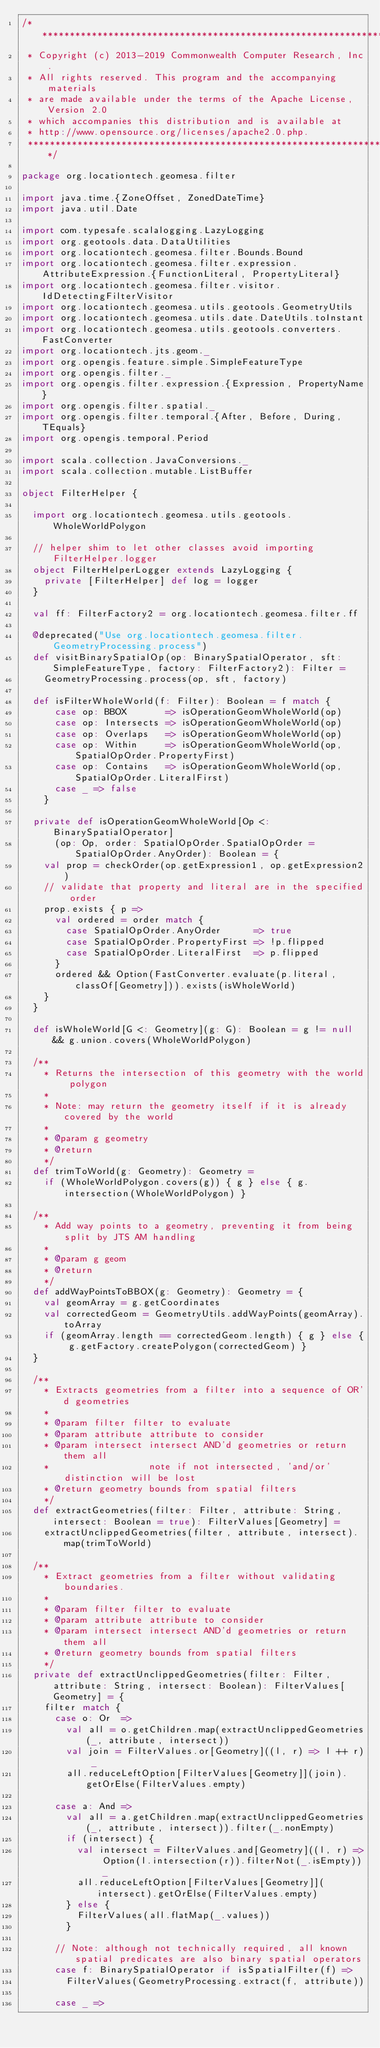<code> <loc_0><loc_0><loc_500><loc_500><_Scala_>/***********************************************************************
 * Copyright (c) 2013-2019 Commonwealth Computer Research, Inc.
 * All rights reserved. This program and the accompanying materials
 * are made available under the terms of the Apache License, Version 2.0
 * which accompanies this distribution and is available at
 * http://www.opensource.org/licenses/apache2.0.php.
 ***********************************************************************/

package org.locationtech.geomesa.filter

import java.time.{ZoneOffset, ZonedDateTime}
import java.util.Date

import com.typesafe.scalalogging.LazyLogging
import org.geotools.data.DataUtilities
import org.locationtech.geomesa.filter.Bounds.Bound
import org.locationtech.geomesa.filter.expression.AttributeExpression.{FunctionLiteral, PropertyLiteral}
import org.locationtech.geomesa.filter.visitor.IdDetectingFilterVisitor
import org.locationtech.geomesa.utils.geotools.GeometryUtils
import org.locationtech.geomesa.utils.date.DateUtils.toInstant
import org.locationtech.geomesa.utils.geotools.converters.FastConverter
import org.locationtech.jts.geom._
import org.opengis.feature.simple.SimpleFeatureType
import org.opengis.filter._
import org.opengis.filter.expression.{Expression, PropertyName}
import org.opengis.filter.spatial._
import org.opengis.filter.temporal.{After, Before, During, TEquals}
import org.opengis.temporal.Period

import scala.collection.JavaConversions._
import scala.collection.mutable.ListBuffer

object FilterHelper {

  import org.locationtech.geomesa.utils.geotools.WholeWorldPolygon

  // helper shim to let other classes avoid importing FilterHelper.logger
  object FilterHelperLogger extends LazyLogging {
    private [FilterHelper] def log = logger
  }

  val ff: FilterFactory2 = org.locationtech.geomesa.filter.ff

  @deprecated("Use org.locationtech.geomesa.filter.GeometryProcessing.process")
  def visitBinarySpatialOp(op: BinarySpatialOperator, sft: SimpleFeatureType, factory: FilterFactory2): Filter =
    GeometryProcessing.process(op, sft, factory)

  def isFilterWholeWorld(f: Filter): Boolean = f match {
      case op: BBOX       => isOperationGeomWholeWorld(op)
      case op: Intersects => isOperationGeomWholeWorld(op)
      case op: Overlaps   => isOperationGeomWholeWorld(op)
      case op: Within     => isOperationGeomWholeWorld(op, SpatialOpOrder.PropertyFirst)
      case op: Contains   => isOperationGeomWholeWorld(op, SpatialOpOrder.LiteralFirst)
      case _ => false
    }

  private def isOperationGeomWholeWorld[Op <: BinarySpatialOperator]
      (op: Op, order: SpatialOpOrder.SpatialOpOrder = SpatialOpOrder.AnyOrder): Boolean = {
    val prop = checkOrder(op.getExpression1, op.getExpression2)
    // validate that property and literal are in the specified order
    prop.exists { p =>
      val ordered = order match {
        case SpatialOpOrder.AnyOrder      => true
        case SpatialOpOrder.PropertyFirst => !p.flipped
        case SpatialOpOrder.LiteralFirst  => p.flipped
      }
      ordered && Option(FastConverter.evaluate(p.literal, classOf[Geometry])).exists(isWholeWorld)
    }
  }

  def isWholeWorld[G <: Geometry](g: G): Boolean = g != null && g.union.covers(WholeWorldPolygon)

  /**
    * Returns the intersection of this geometry with the world polygon
    *
    * Note: may return the geometry itself if it is already covered by the world
    *
    * @param g geometry
    * @return
    */
  def trimToWorld(g: Geometry): Geometry =
    if (WholeWorldPolygon.covers(g)) { g } else { g.intersection(WholeWorldPolygon) }

  /**
    * Add way points to a geometry, preventing it from being split by JTS AM handling
    *
    * @param g geom
    * @return
    */
  def addWayPointsToBBOX(g: Geometry): Geometry = {
    val geomArray = g.getCoordinates
    val correctedGeom = GeometryUtils.addWayPoints(geomArray).toArray
    if (geomArray.length == correctedGeom.length) { g } else { g.getFactory.createPolygon(correctedGeom) }
  }

  /**
    * Extracts geometries from a filter into a sequence of OR'd geometries
    *
    * @param filter filter to evaluate
    * @param attribute attribute to consider
    * @param intersect intersect AND'd geometries or return them all
    *                  note if not intersected, 'and/or' distinction will be lost
    * @return geometry bounds from spatial filters
    */
  def extractGeometries(filter: Filter, attribute: String, intersect: Boolean = true): FilterValues[Geometry] =
    extractUnclippedGeometries(filter, attribute, intersect).map(trimToWorld)

  /**
    * Extract geometries from a filter without validating boundaries.
    *
    * @param filter filter to evaluate
    * @param attribute attribute to consider
    * @param intersect intersect AND'd geometries or return them all
    * @return geometry bounds from spatial filters
    */
  private def extractUnclippedGeometries(filter: Filter, attribute: String, intersect: Boolean): FilterValues[Geometry] = {
    filter match {
      case o: Or  =>
        val all = o.getChildren.map(extractUnclippedGeometries(_, attribute, intersect))
        val join = FilterValues.or[Geometry]((l, r) => l ++ r) _
        all.reduceLeftOption[FilterValues[Geometry]](join).getOrElse(FilterValues.empty)

      case a: And =>
        val all = a.getChildren.map(extractUnclippedGeometries(_, attribute, intersect)).filter(_.nonEmpty)
        if (intersect) {
          val intersect = FilterValues.and[Geometry]((l, r) => Option(l.intersection(r)).filterNot(_.isEmpty)) _
          all.reduceLeftOption[FilterValues[Geometry]](intersect).getOrElse(FilterValues.empty)
        } else {
          FilterValues(all.flatMap(_.values))
        }

      // Note: although not technically required, all known spatial predicates are also binary spatial operators
      case f: BinarySpatialOperator if isSpatialFilter(f) =>
        FilterValues(GeometryProcessing.extract(f, attribute))

      case _ =></code> 